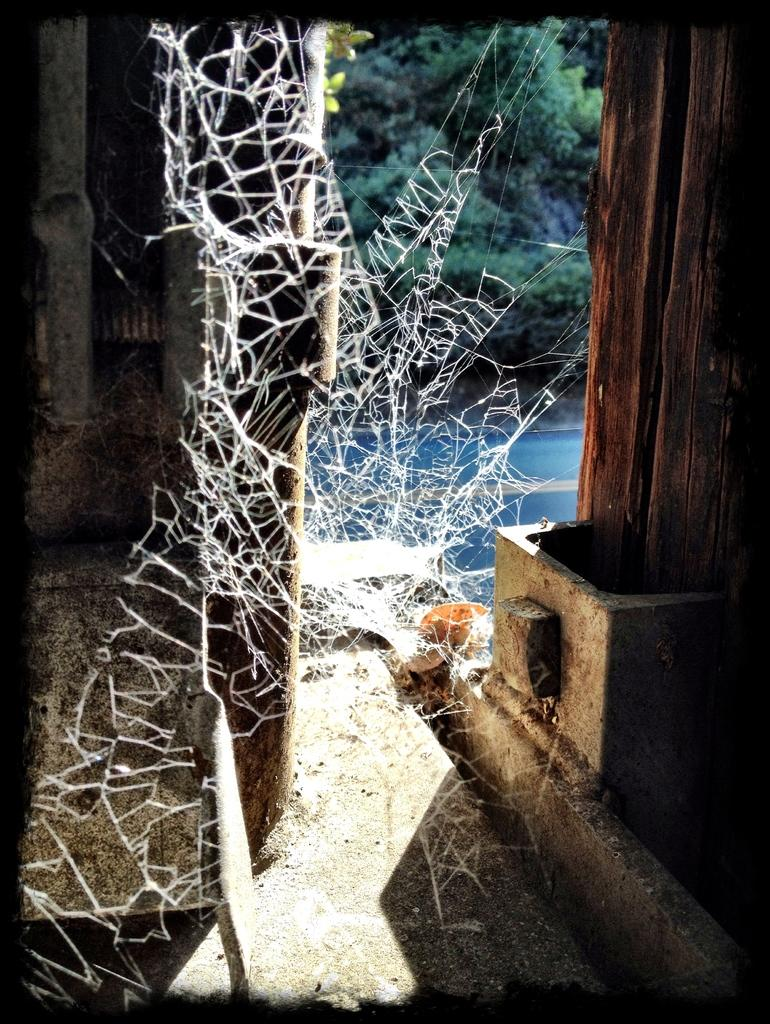What is the main subject of the image? The main subject of the image is a web. What can be seen in the background of the image? In the background of the image, there are wooden objects, a road, trees, a walkway, and other objects. Can you describe the wooden objects in the background? The wooden objects in the background are not specified, but they are present. What type of pie is being served by the laborer in the image? There is no laborer or pie present in the image; it features a web and various objects in the background. 